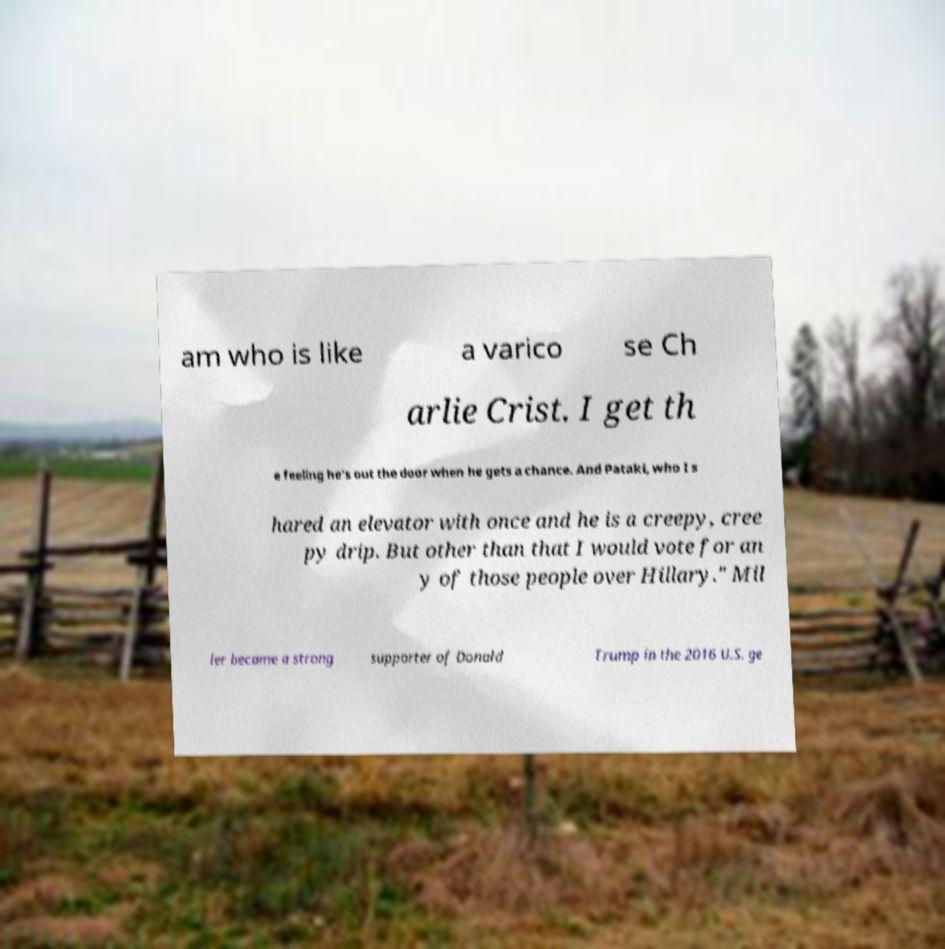Please identify and transcribe the text found in this image. am who is like a varico se Ch arlie Crist. I get th e feeling he's out the door when he gets a chance. And Pataki, who I s hared an elevator with once and he is a creepy, cree py drip. But other than that I would vote for an y of those people over Hillary." Mil ler became a strong supporter of Donald Trump in the 2016 U.S. ge 